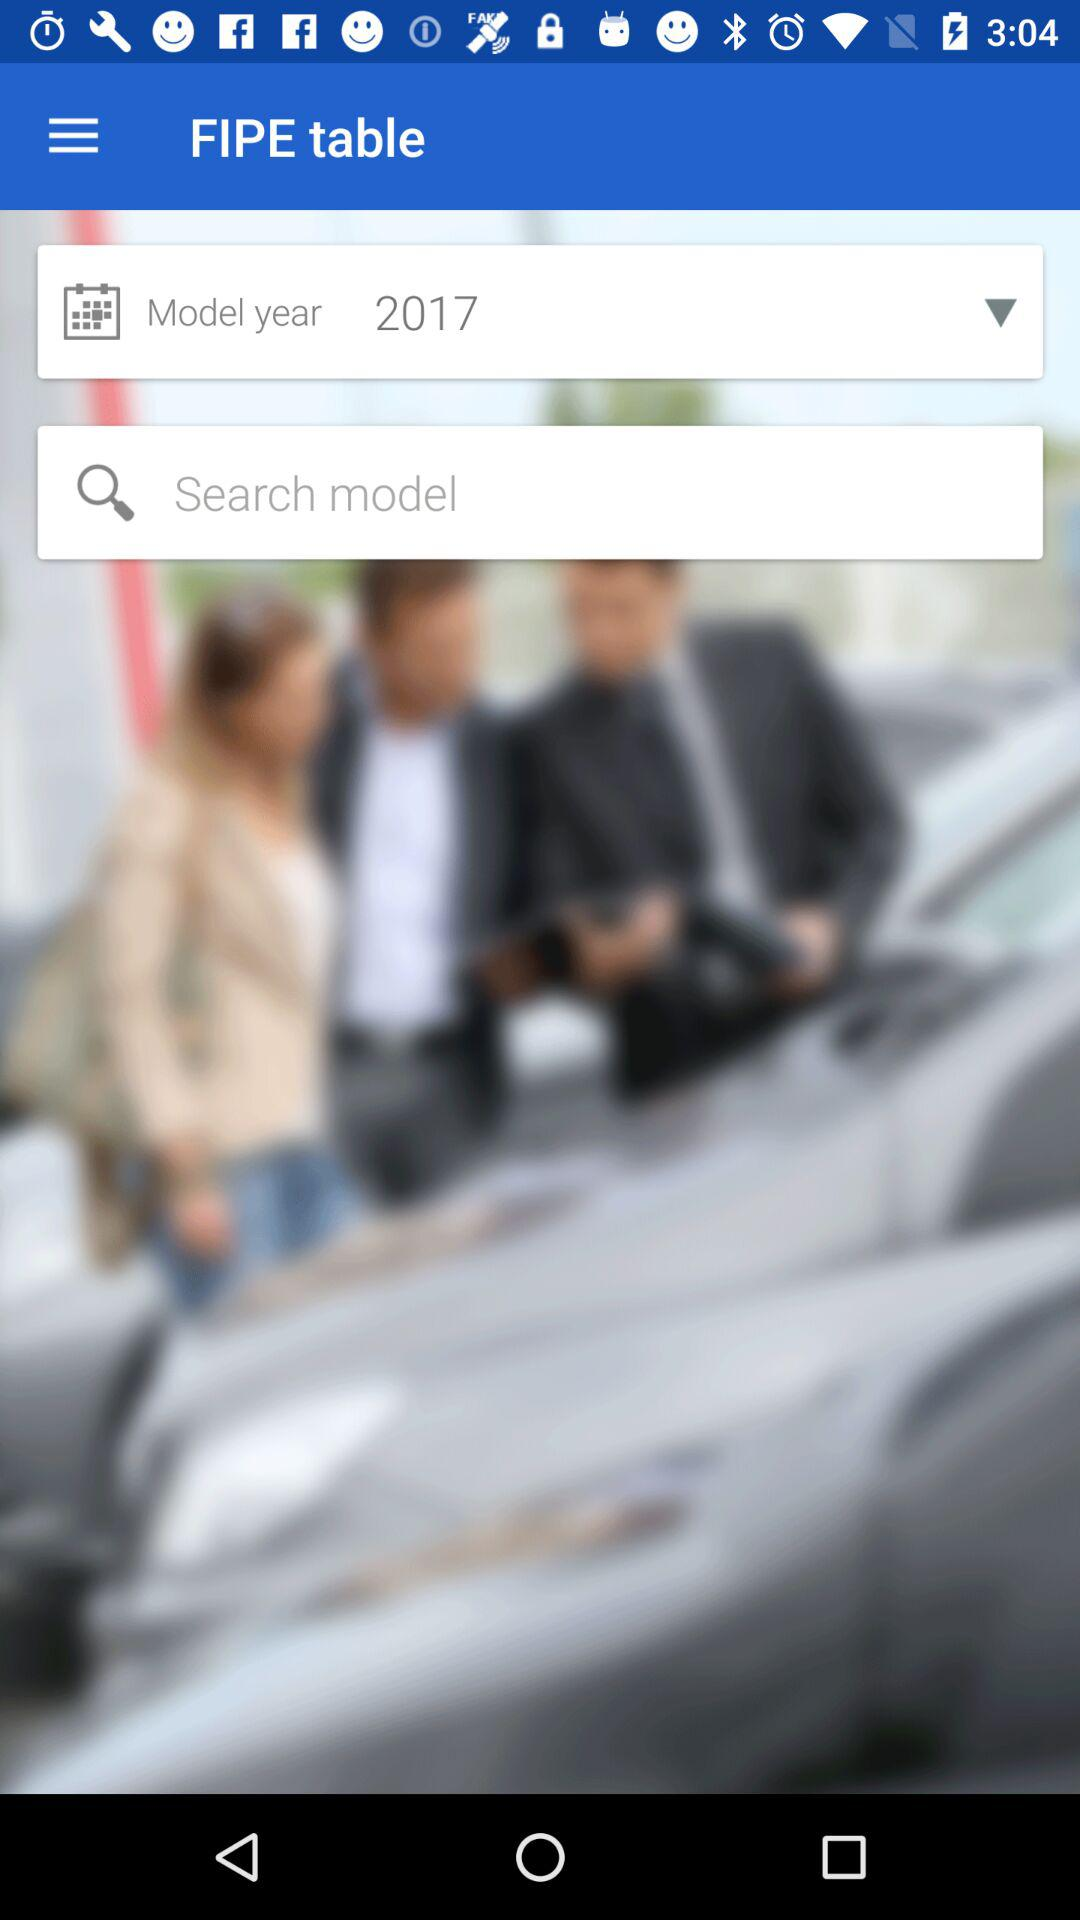Which model month was selected?
When the provided information is insufficient, respond with <no answer>. <no answer> 